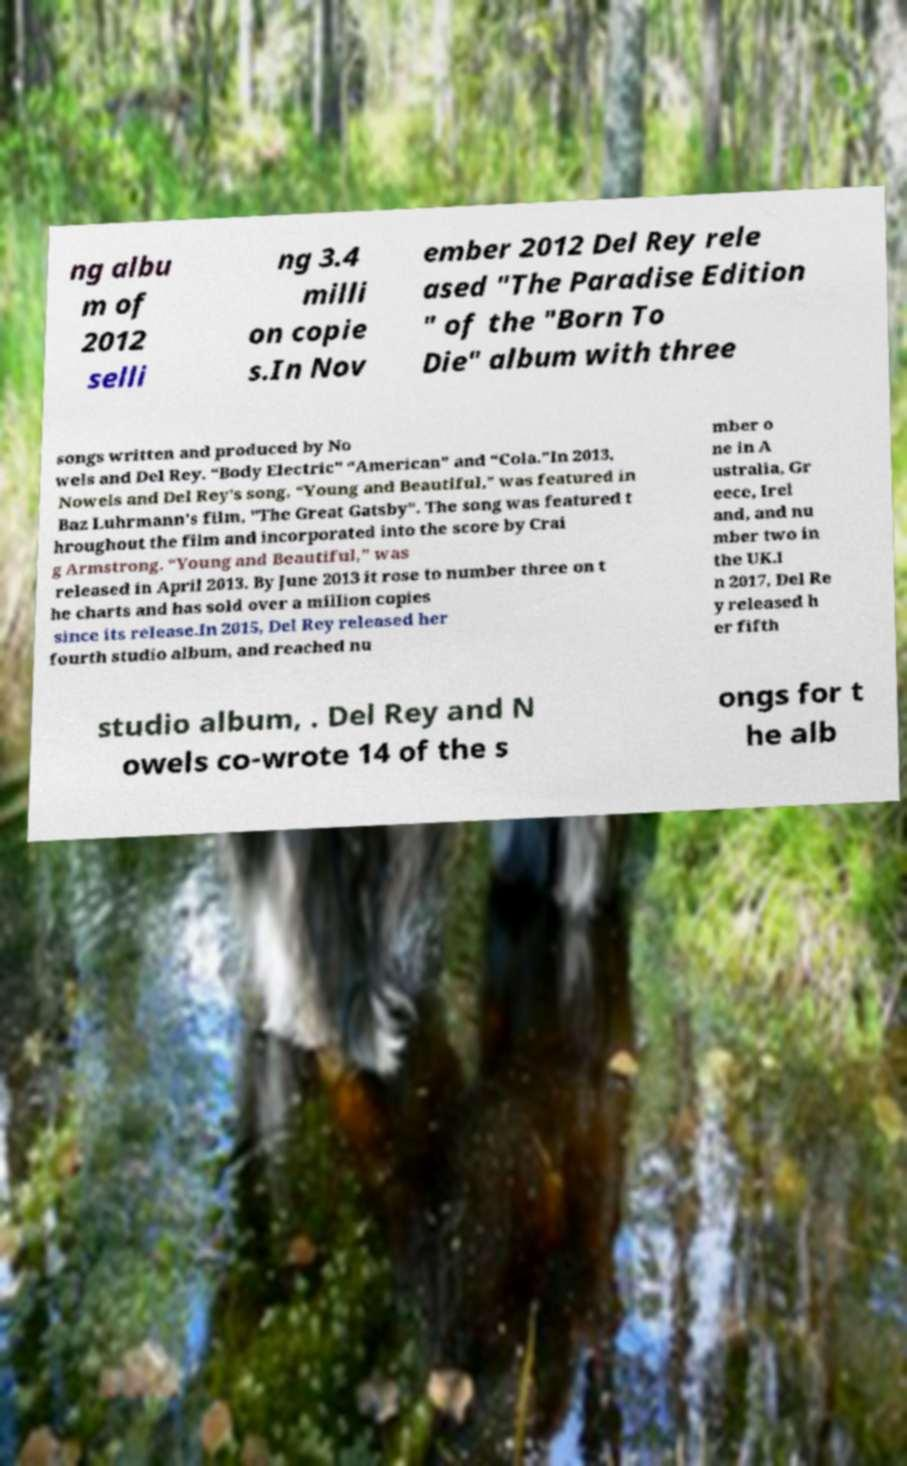Please identify and transcribe the text found in this image. ng albu m of 2012 selli ng 3.4 milli on copie s.In Nov ember 2012 Del Rey rele ased "The Paradise Edition " of the "Born To Die" album with three songs written and produced by No wels and Del Rey. “Body Electric" “American” and “Cola.”In 2013, Nowels and Del Rey's song, “Young and Beautiful,” was featured in Baz Luhrmann’s film, "The Great Gatsby". The song was featured t hroughout the film and incorporated into the score by Crai g Armstrong. “Young and Beautiful,” was released in April 2013. By June 2013 it rose to number three on t he charts and has sold over a million copies since its release.In 2015, Del Rey released her fourth studio album, and reached nu mber o ne in A ustralia, Gr eece, Irel and, and nu mber two in the UK.I n 2017, Del Re y released h er fifth studio album, . Del Rey and N owels co-wrote 14 of the s ongs for t he alb 